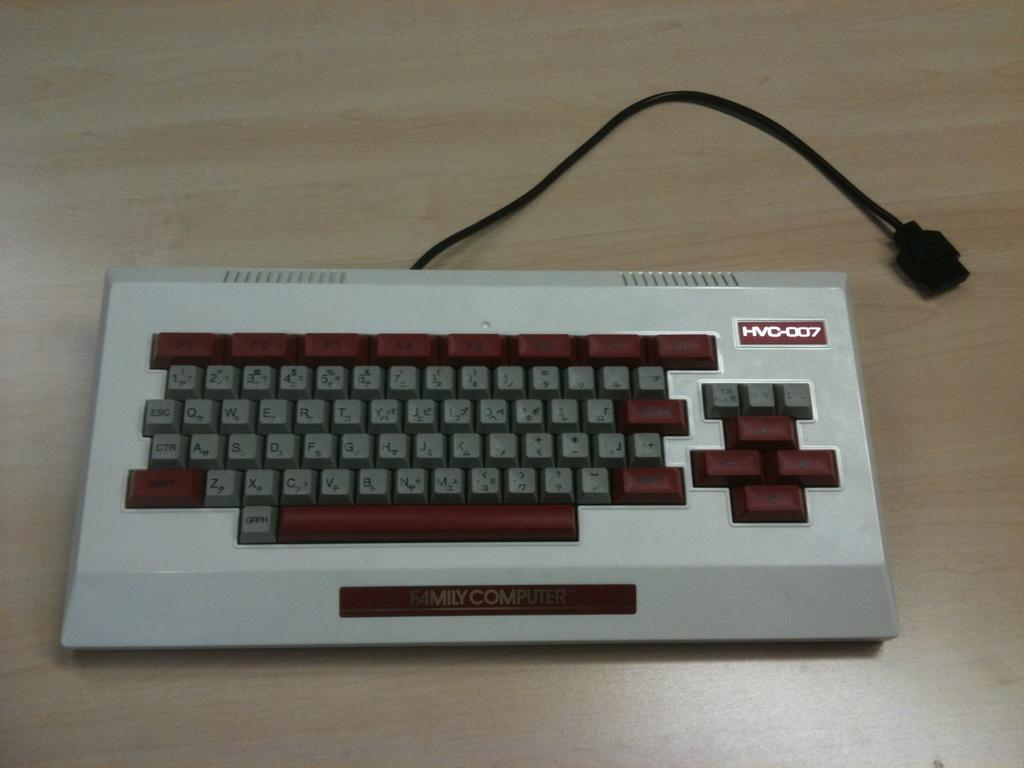Provide a one-sentence caption for the provided image. The bulky HVC-007 is placed on an otherwise empty table top. 